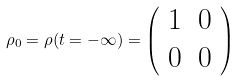<formula> <loc_0><loc_0><loc_500><loc_500>\rho _ { 0 } = \rho ( t = - \infty ) = \left ( \begin{array} { c c } 1 & 0 \\ 0 & 0 \end{array} \right )</formula> 